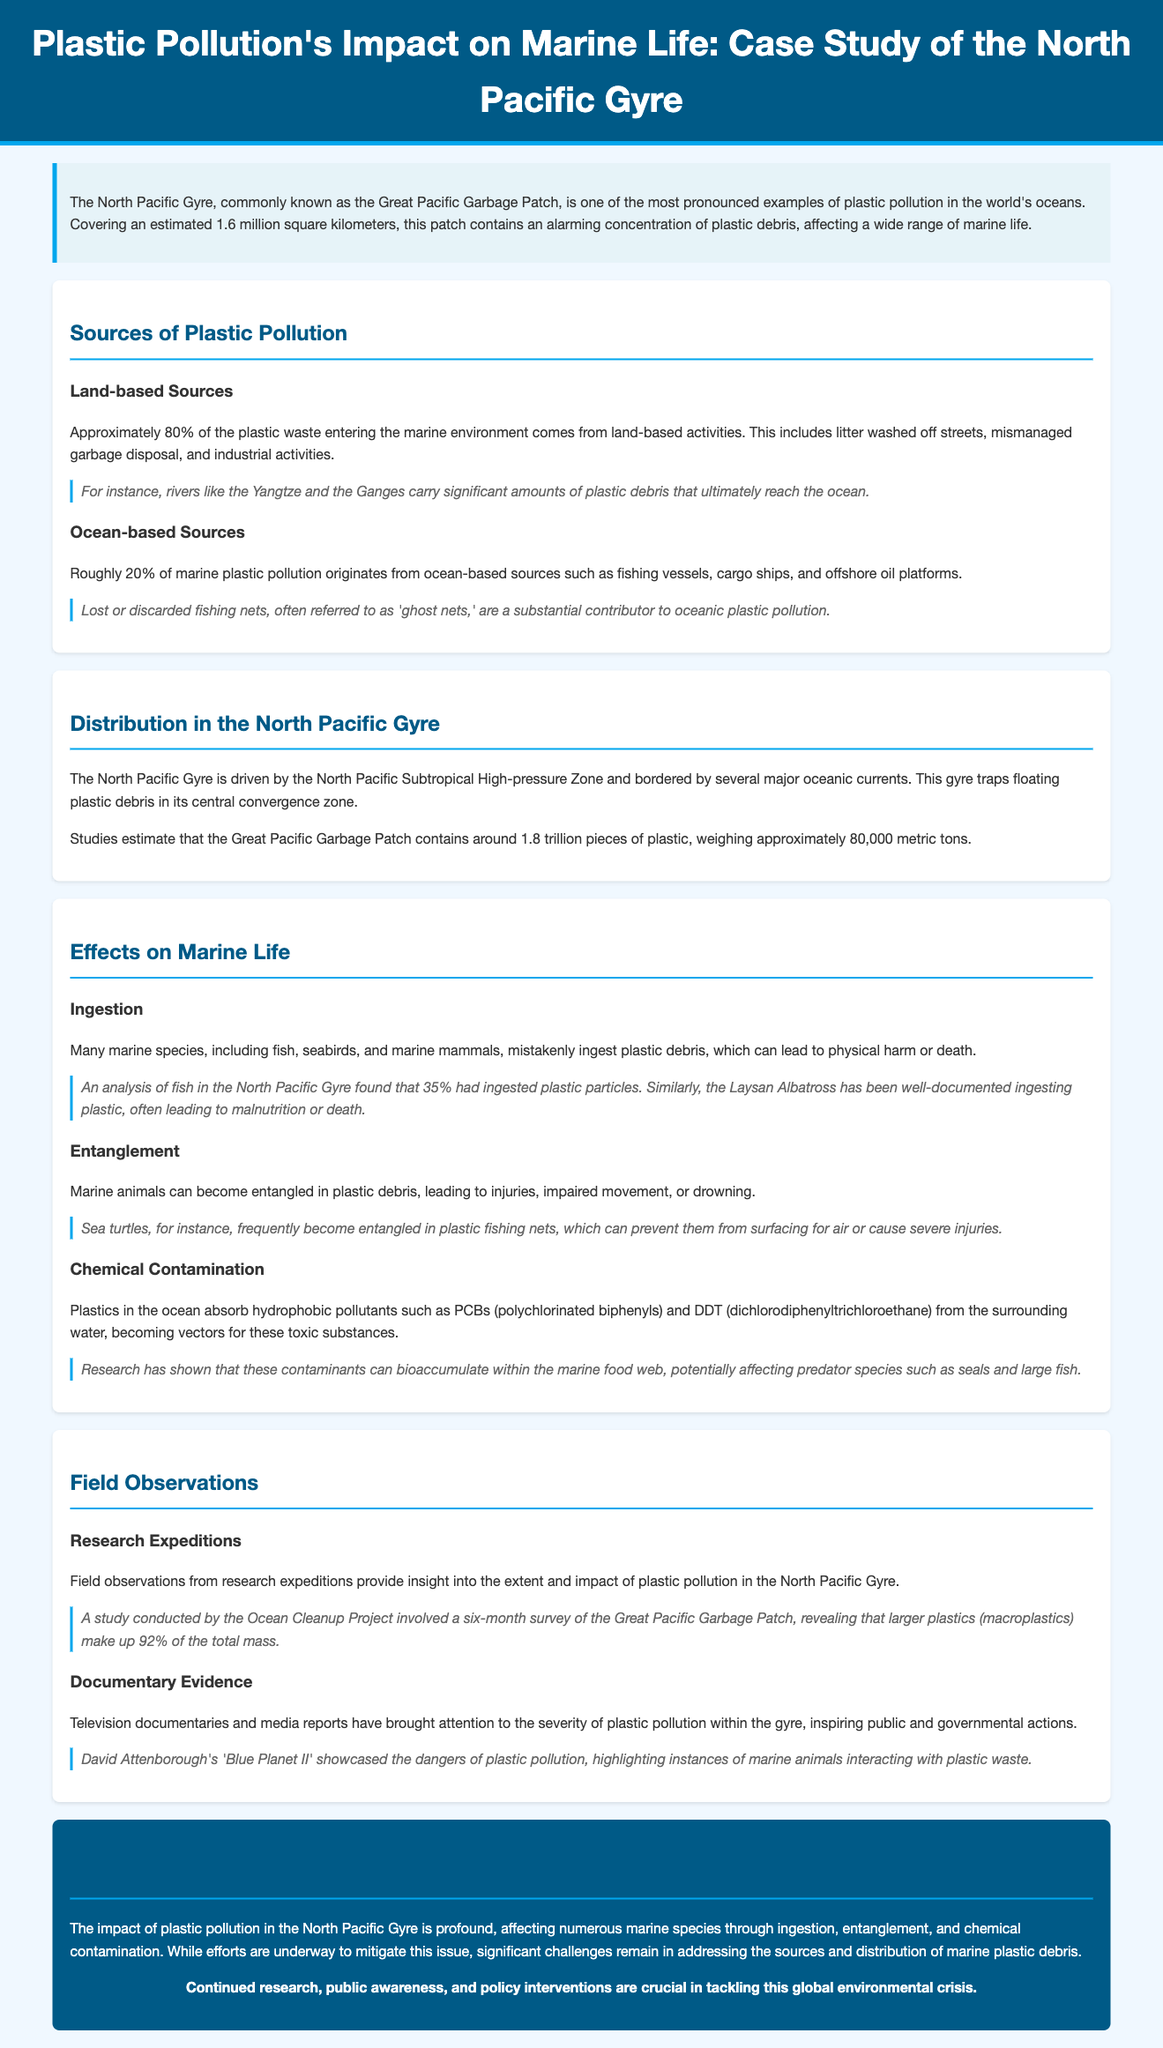what percentage of plastic waste comes from land-based sources? The document states that approximately 80% of plastic waste entering the marine environment comes from land-based activities.
Answer: 80% how many pieces of plastic are estimated to be in the Great Pacific Garbage Patch? The document mentions that studies estimate the Great Pacific Garbage Patch contains around 1.8 trillion pieces of plastic.
Answer: 1.8 trillion which marine animal is mentioned as ingesting plastic debris? The Laysan Albatross is well-documented for ingesting plastic, leading to malnutrition or death.
Answer: Laysan Albatross what is one major source of ocean-based plastic pollution? The document identifies lost or discarded fishing nets, known as 'ghost nets,' as a substantial contributor.
Answer: ghost nets how much does the plastic in the Great Pacific Garbage Patch weigh? The document indicates that the plastic debris weighs approximately 80,000 metric tons.
Answer: 80,000 metric tons what is the impact of plastics absorbing hydrophobic pollutants on marine life? The document explains that plastics absorb pollutants like PCBs and DDT, which can bioaccumulate and affect predator species.
Answer: bioaccumulate what percentage of larger plastics make up the total mass of the Great Pacific Garbage Patch? According to the document, larger plastics (macroplastics) make up 92% of the total mass.
Answer: 92% who highlighted the dangers of plastic pollution in a documentary? David Attenborough showcased the dangers of plastic pollution in 'Blue Planet II.'
Answer: David Attenborough 